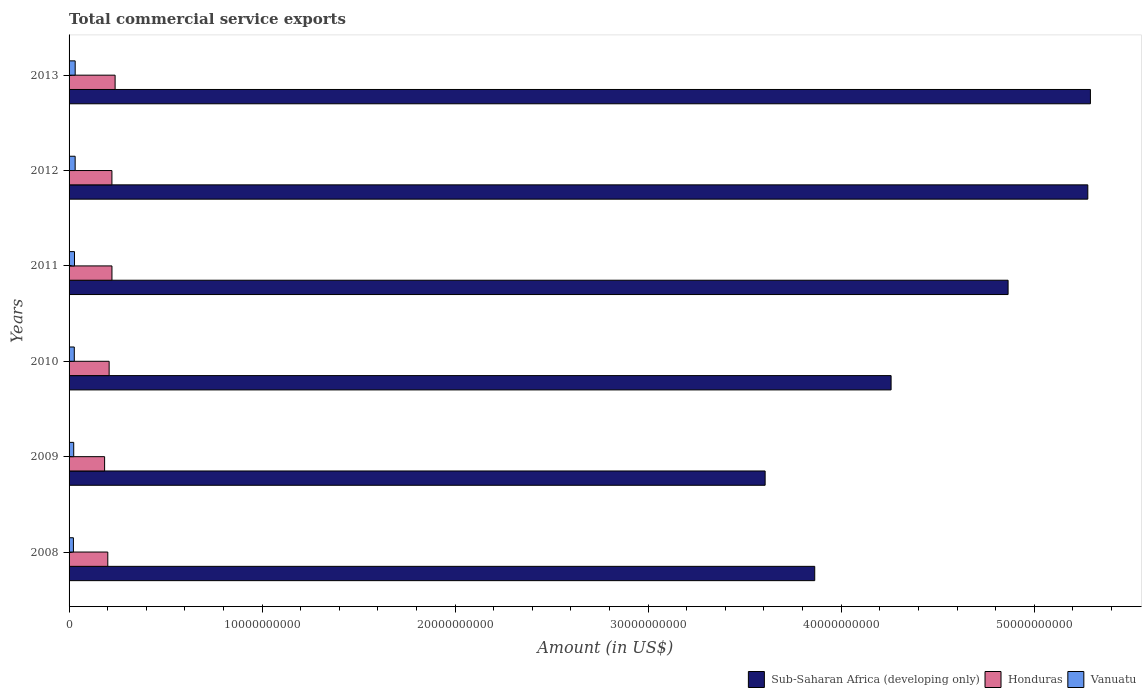How many groups of bars are there?
Your answer should be compact. 6. Are the number of bars per tick equal to the number of legend labels?
Make the answer very short. Yes. What is the label of the 1st group of bars from the top?
Provide a short and direct response. 2013. What is the total commercial service exports in Honduras in 2008?
Make the answer very short. 2.01e+09. Across all years, what is the maximum total commercial service exports in Vanuatu?
Offer a terse response. 3.17e+08. Across all years, what is the minimum total commercial service exports in Sub-Saharan Africa (developing only)?
Ensure brevity in your answer.  3.61e+1. What is the total total commercial service exports in Sub-Saharan Africa (developing only) in the graph?
Provide a succinct answer. 2.72e+11. What is the difference between the total commercial service exports in Sub-Saharan Africa (developing only) in 2010 and that in 2011?
Offer a very short reply. -6.06e+09. What is the difference between the total commercial service exports in Sub-Saharan Africa (developing only) in 2011 and the total commercial service exports in Vanuatu in 2012?
Ensure brevity in your answer.  4.83e+1. What is the average total commercial service exports in Honduras per year?
Offer a very short reply. 2.12e+09. In the year 2009, what is the difference between the total commercial service exports in Vanuatu and total commercial service exports in Sub-Saharan Africa (developing only)?
Offer a terse response. -3.58e+1. In how many years, is the total commercial service exports in Sub-Saharan Africa (developing only) greater than 30000000000 US$?
Ensure brevity in your answer.  6. What is the ratio of the total commercial service exports in Sub-Saharan Africa (developing only) in 2008 to that in 2013?
Ensure brevity in your answer.  0.73. What is the difference between the highest and the second highest total commercial service exports in Sub-Saharan Africa (developing only)?
Offer a terse response. 1.35e+08. What is the difference between the highest and the lowest total commercial service exports in Vanuatu?
Offer a terse response. 9.15e+07. What does the 1st bar from the top in 2011 represents?
Your answer should be very brief. Vanuatu. What does the 3rd bar from the bottom in 2012 represents?
Your answer should be very brief. Vanuatu. How many years are there in the graph?
Offer a terse response. 6. What is the difference between two consecutive major ticks on the X-axis?
Keep it short and to the point. 1.00e+1. Are the values on the major ticks of X-axis written in scientific E-notation?
Offer a terse response. No. Does the graph contain grids?
Ensure brevity in your answer.  No. Where does the legend appear in the graph?
Provide a succinct answer. Bottom right. How are the legend labels stacked?
Your answer should be very brief. Horizontal. What is the title of the graph?
Your answer should be very brief. Total commercial service exports. What is the Amount (in US$) in Sub-Saharan Africa (developing only) in 2008?
Give a very brief answer. 3.86e+1. What is the Amount (in US$) of Honduras in 2008?
Offer a terse response. 2.01e+09. What is the Amount (in US$) of Vanuatu in 2008?
Provide a short and direct response. 2.25e+08. What is the Amount (in US$) in Sub-Saharan Africa (developing only) in 2009?
Keep it short and to the point. 3.61e+1. What is the Amount (in US$) in Honduras in 2009?
Give a very brief answer. 1.84e+09. What is the Amount (in US$) of Vanuatu in 2009?
Your answer should be compact. 2.41e+08. What is the Amount (in US$) of Sub-Saharan Africa (developing only) in 2010?
Give a very brief answer. 4.26e+1. What is the Amount (in US$) in Honduras in 2010?
Provide a short and direct response. 2.08e+09. What is the Amount (in US$) in Vanuatu in 2010?
Your response must be concise. 2.71e+08. What is the Amount (in US$) in Sub-Saharan Africa (developing only) in 2011?
Keep it short and to the point. 4.86e+1. What is the Amount (in US$) of Honduras in 2011?
Provide a succinct answer. 2.22e+09. What is the Amount (in US$) of Vanuatu in 2011?
Ensure brevity in your answer.  2.81e+08. What is the Amount (in US$) in Sub-Saharan Africa (developing only) in 2012?
Provide a succinct answer. 5.28e+1. What is the Amount (in US$) in Honduras in 2012?
Make the answer very short. 2.22e+09. What is the Amount (in US$) of Vanuatu in 2012?
Your answer should be very brief. 3.15e+08. What is the Amount (in US$) of Sub-Saharan Africa (developing only) in 2013?
Provide a succinct answer. 5.29e+1. What is the Amount (in US$) of Honduras in 2013?
Give a very brief answer. 2.39e+09. What is the Amount (in US$) in Vanuatu in 2013?
Provide a short and direct response. 3.17e+08. Across all years, what is the maximum Amount (in US$) in Sub-Saharan Africa (developing only)?
Ensure brevity in your answer.  5.29e+1. Across all years, what is the maximum Amount (in US$) of Honduras?
Give a very brief answer. 2.39e+09. Across all years, what is the maximum Amount (in US$) of Vanuatu?
Make the answer very short. 3.17e+08. Across all years, what is the minimum Amount (in US$) of Sub-Saharan Africa (developing only)?
Ensure brevity in your answer.  3.61e+1. Across all years, what is the minimum Amount (in US$) in Honduras?
Make the answer very short. 1.84e+09. Across all years, what is the minimum Amount (in US$) in Vanuatu?
Your answer should be compact. 2.25e+08. What is the total Amount (in US$) of Sub-Saharan Africa (developing only) in the graph?
Ensure brevity in your answer.  2.72e+11. What is the total Amount (in US$) of Honduras in the graph?
Make the answer very short. 1.27e+1. What is the total Amount (in US$) in Vanuatu in the graph?
Keep it short and to the point. 1.65e+09. What is the difference between the Amount (in US$) of Sub-Saharan Africa (developing only) in 2008 and that in 2009?
Offer a very short reply. 2.57e+09. What is the difference between the Amount (in US$) of Honduras in 2008 and that in 2009?
Ensure brevity in your answer.  1.65e+08. What is the difference between the Amount (in US$) in Vanuatu in 2008 and that in 2009?
Make the answer very short. -1.57e+07. What is the difference between the Amount (in US$) in Sub-Saharan Africa (developing only) in 2008 and that in 2010?
Your answer should be very brief. -3.96e+09. What is the difference between the Amount (in US$) in Honduras in 2008 and that in 2010?
Provide a succinct answer. -6.97e+07. What is the difference between the Amount (in US$) in Vanuatu in 2008 and that in 2010?
Your response must be concise. -4.59e+07. What is the difference between the Amount (in US$) of Sub-Saharan Africa (developing only) in 2008 and that in 2011?
Offer a terse response. -1.00e+1. What is the difference between the Amount (in US$) of Honduras in 2008 and that in 2011?
Your answer should be compact. -2.15e+08. What is the difference between the Amount (in US$) in Vanuatu in 2008 and that in 2011?
Provide a succinct answer. -5.62e+07. What is the difference between the Amount (in US$) in Sub-Saharan Africa (developing only) in 2008 and that in 2012?
Your answer should be compact. -1.41e+1. What is the difference between the Amount (in US$) in Honduras in 2008 and that in 2012?
Offer a terse response. -2.14e+08. What is the difference between the Amount (in US$) of Vanuatu in 2008 and that in 2012?
Your response must be concise. -9.00e+07. What is the difference between the Amount (in US$) in Sub-Saharan Africa (developing only) in 2008 and that in 2013?
Keep it short and to the point. -1.43e+1. What is the difference between the Amount (in US$) of Honduras in 2008 and that in 2013?
Offer a very short reply. -3.79e+08. What is the difference between the Amount (in US$) of Vanuatu in 2008 and that in 2013?
Offer a terse response. -9.15e+07. What is the difference between the Amount (in US$) of Sub-Saharan Africa (developing only) in 2009 and that in 2010?
Your answer should be compact. -6.53e+09. What is the difference between the Amount (in US$) in Honduras in 2009 and that in 2010?
Offer a terse response. -2.35e+08. What is the difference between the Amount (in US$) of Vanuatu in 2009 and that in 2010?
Provide a short and direct response. -3.02e+07. What is the difference between the Amount (in US$) of Sub-Saharan Africa (developing only) in 2009 and that in 2011?
Make the answer very short. -1.26e+1. What is the difference between the Amount (in US$) in Honduras in 2009 and that in 2011?
Keep it short and to the point. -3.80e+08. What is the difference between the Amount (in US$) of Vanuatu in 2009 and that in 2011?
Your response must be concise. -4.05e+07. What is the difference between the Amount (in US$) in Sub-Saharan Africa (developing only) in 2009 and that in 2012?
Offer a very short reply. -1.67e+1. What is the difference between the Amount (in US$) in Honduras in 2009 and that in 2012?
Give a very brief answer. -3.79e+08. What is the difference between the Amount (in US$) in Vanuatu in 2009 and that in 2012?
Provide a short and direct response. -7.43e+07. What is the difference between the Amount (in US$) of Sub-Saharan Africa (developing only) in 2009 and that in 2013?
Your answer should be very brief. -1.69e+1. What is the difference between the Amount (in US$) of Honduras in 2009 and that in 2013?
Your answer should be very brief. -5.45e+08. What is the difference between the Amount (in US$) in Vanuatu in 2009 and that in 2013?
Keep it short and to the point. -7.58e+07. What is the difference between the Amount (in US$) of Sub-Saharan Africa (developing only) in 2010 and that in 2011?
Make the answer very short. -6.06e+09. What is the difference between the Amount (in US$) in Honduras in 2010 and that in 2011?
Ensure brevity in your answer.  -1.45e+08. What is the difference between the Amount (in US$) in Vanuatu in 2010 and that in 2011?
Offer a very short reply. -1.03e+07. What is the difference between the Amount (in US$) of Sub-Saharan Africa (developing only) in 2010 and that in 2012?
Provide a short and direct response. -1.02e+1. What is the difference between the Amount (in US$) in Honduras in 2010 and that in 2012?
Your answer should be very brief. -1.44e+08. What is the difference between the Amount (in US$) of Vanuatu in 2010 and that in 2012?
Make the answer very short. -4.41e+07. What is the difference between the Amount (in US$) in Sub-Saharan Africa (developing only) in 2010 and that in 2013?
Offer a very short reply. -1.03e+1. What is the difference between the Amount (in US$) in Honduras in 2010 and that in 2013?
Your answer should be compact. -3.10e+08. What is the difference between the Amount (in US$) in Vanuatu in 2010 and that in 2013?
Offer a terse response. -4.56e+07. What is the difference between the Amount (in US$) of Sub-Saharan Africa (developing only) in 2011 and that in 2012?
Give a very brief answer. -4.13e+09. What is the difference between the Amount (in US$) in Honduras in 2011 and that in 2012?
Your answer should be very brief. 1.30e+06. What is the difference between the Amount (in US$) of Vanuatu in 2011 and that in 2012?
Your answer should be compact. -3.38e+07. What is the difference between the Amount (in US$) in Sub-Saharan Africa (developing only) in 2011 and that in 2013?
Your answer should be compact. -4.27e+09. What is the difference between the Amount (in US$) in Honduras in 2011 and that in 2013?
Give a very brief answer. -1.64e+08. What is the difference between the Amount (in US$) in Vanuatu in 2011 and that in 2013?
Your answer should be compact. -3.53e+07. What is the difference between the Amount (in US$) of Sub-Saharan Africa (developing only) in 2012 and that in 2013?
Your response must be concise. -1.35e+08. What is the difference between the Amount (in US$) of Honduras in 2012 and that in 2013?
Give a very brief answer. -1.65e+08. What is the difference between the Amount (in US$) in Vanuatu in 2012 and that in 2013?
Ensure brevity in your answer.  -1.54e+06. What is the difference between the Amount (in US$) in Sub-Saharan Africa (developing only) in 2008 and the Amount (in US$) in Honduras in 2009?
Provide a succinct answer. 3.68e+1. What is the difference between the Amount (in US$) of Sub-Saharan Africa (developing only) in 2008 and the Amount (in US$) of Vanuatu in 2009?
Your answer should be compact. 3.84e+1. What is the difference between the Amount (in US$) in Honduras in 2008 and the Amount (in US$) in Vanuatu in 2009?
Give a very brief answer. 1.77e+09. What is the difference between the Amount (in US$) in Sub-Saharan Africa (developing only) in 2008 and the Amount (in US$) in Honduras in 2010?
Your response must be concise. 3.66e+1. What is the difference between the Amount (in US$) of Sub-Saharan Africa (developing only) in 2008 and the Amount (in US$) of Vanuatu in 2010?
Make the answer very short. 3.84e+1. What is the difference between the Amount (in US$) in Honduras in 2008 and the Amount (in US$) in Vanuatu in 2010?
Your answer should be very brief. 1.73e+09. What is the difference between the Amount (in US$) in Sub-Saharan Africa (developing only) in 2008 and the Amount (in US$) in Honduras in 2011?
Give a very brief answer. 3.64e+1. What is the difference between the Amount (in US$) in Sub-Saharan Africa (developing only) in 2008 and the Amount (in US$) in Vanuatu in 2011?
Offer a very short reply. 3.83e+1. What is the difference between the Amount (in US$) of Honduras in 2008 and the Amount (in US$) of Vanuatu in 2011?
Give a very brief answer. 1.72e+09. What is the difference between the Amount (in US$) of Sub-Saharan Africa (developing only) in 2008 and the Amount (in US$) of Honduras in 2012?
Keep it short and to the point. 3.64e+1. What is the difference between the Amount (in US$) in Sub-Saharan Africa (developing only) in 2008 and the Amount (in US$) in Vanuatu in 2012?
Provide a succinct answer. 3.83e+1. What is the difference between the Amount (in US$) of Honduras in 2008 and the Amount (in US$) of Vanuatu in 2012?
Give a very brief answer. 1.69e+09. What is the difference between the Amount (in US$) of Sub-Saharan Africa (developing only) in 2008 and the Amount (in US$) of Honduras in 2013?
Provide a succinct answer. 3.62e+1. What is the difference between the Amount (in US$) in Sub-Saharan Africa (developing only) in 2008 and the Amount (in US$) in Vanuatu in 2013?
Make the answer very short. 3.83e+1. What is the difference between the Amount (in US$) in Honduras in 2008 and the Amount (in US$) in Vanuatu in 2013?
Keep it short and to the point. 1.69e+09. What is the difference between the Amount (in US$) of Sub-Saharan Africa (developing only) in 2009 and the Amount (in US$) of Honduras in 2010?
Ensure brevity in your answer.  3.40e+1. What is the difference between the Amount (in US$) of Sub-Saharan Africa (developing only) in 2009 and the Amount (in US$) of Vanuatu in 2010?
Make the answer very short. 3.58e+1. What is the difference between the Amount (in US$) of Honduras in 2009 and the Amount (in US$) of Vanuatu in 2010?
Make the answer very short. 1.57e+09. What is the difference between the Amount (in US$) in Sub-Saharan Africa (developing only) in 2009 and the Amount (in US$) in Honduras in 2011?
Provide a short and direct response. 3.38e+1. What is the difference between the Amount (in US$) in Sub-Saharan Africa (developing only) in 2009 and the Amount (in US$) in Vanuatu in 2011?
Your answer should be compact. 3.58e+1. What is the difference between the Amount (in US$) in Honduras in 2009 and the Amount (in US$) in Vanuatu in 2011?
Keep it short and to the point. 1.56e+09. What is the difference between the Amount (in US$) of Sub-Saharan Africa (developing only) in 2009 and the Amount (in US$) of Honduras in 2012?
Offer a terse response. 3.38e+1. What is the difference between the Amount (in US$) of Sub-Saharan Africa (developing only) in 2009 and the Amount (in US$) of Vanuatu in 2012?
Your response must be concise. 3.57e+1. What is the difference between the Amount (in US$) of Honduras in 2009 and the Amount (in US$) of Vanuatu in 2012?
Give a very brief answer. 1.53e+09. What is the difference between the Amount (in US$) of Sub-Saharan Africa (developing only) in 2009 and the Amount (in US$) of Honduras in 2013?
Ensure brevity in your answer.  3.37e+1. What is the difference between the Amount (in US$) in Sub-Saharan Africa (developing only) in 2009 and the Amount (in US$) in Vanuatu in 2013?
Offer a terse response. 3.57e+1. What is the difference between the Amount (in US$) of Honduras in 2009 and the Amount (in US$) of Vanuatu in 2013?
Provide a short and direct response. 1.52e+09. What is the difference between the Amount (in US$) of Sub-Saharan Africa (developing only) in 2010 and the Amount (in US$) of Honduras in 2011?
Provide a succinct answer. 4.04e+1. What is the difference between the Amount (in US$) of Sub-Saharan Africa (developing only) in 2010 and the Amount (in US$) of Vanuatu in 2011?
Give a very brief answer. 4.23e+1. What is the difference between the Amount (in US$) of Honduras in 2010 and the Amount (in US$) of Vanuatu in 2011?
Provide a short and direct response. 1.79e+09. What is the difference between the Amount (in US$) of Sub-Saharan Africa (developing only) in 2010 and the Amount (in US$) of Honduras in 2012?
Ensure brevity in your answer.  4.04e+1. What is the difference between the Amount (in US$) in Sub-Saharan Africa (developing only) in 2010 and the Amount (in US$) in Vanuatu in 2012?
Your response must be concise. 4.23e+1. What is the difference between the Amount (in US$) in Honduras in 2010 and the Amount (in US$) in Vanuatu in 2012?
Your answer should be compact. 1.76e+09. What is the difference between the Amount (in US$) in Sub-Saharan Africa (developing only) in 2010 and the Amount (in US$) in Honduras in 2013?
Offer a very short reply. 4.02e+1. What is the difference between the Amount (in US$) of Sub-Saharan Africa (developing only) in 2010 and the Amount (in US$) of Vanuatu in 2013?
Offer a very short reply. 4.23e+1. What is the difference between the Amount (in US$) in Honduras in 2010 and the Amount (in US$) in Vanuatu in 2013?
Offer a very short reply. 1.76e+09. What is the difference between the Amount (in US$) in Sub-Saharan Africa (developing only) in 2011 and the Amount (in US$) in Honduras in 2012?
Keep it short and to the point. 4.64e+1. What is the difference between the Amount (in US$) of Sub-Saharan Africa (developing only) in 2011 and the Amount (in US$) of Vanuatu in 2012?
Keep it short and to the point. 4.83e+1. What is the difference between the Amount (in US$) of Honduras in 2011 and the Amount (in US$) of Vanuatu in 2012?
Your answer should be very brief. 1.91e+09. What is the difference between the Amount (in US$) in Sub-Saharan Africa (developing only) in 2011 and the Amount (in US$) in Honduras in 2013?
Keep it short and to the point. 4.63e+1. What is the difference between the Amount (in US$) in Sub-Saharan Africa (developing only) in 2011 and the Amount (in US$) in Vanuatu in 2013?
Your answer should be very brief. 4.83e+1. What is the difference between the Amount (in US$) in Honduras in 2011 and the Amount (in US$) in Vanuatu in 2013?
Your answer should be very brief. 1.90e+09. What is the difference between the Amount (in US$) of Sub-Saharan Africa (developing only) in 2012 and the Amount (in US$) of Honduras in 2013?
Give a very brief answer. 5.04e+1. What is the difference between the Amount (in US$) in Sub-Saharan Africa (developing only) in 2012 and the Amount (in US$) in Vanuatu in 2013?
Your answer should be compact. 5.25e+1. What is the difference between the Amount (in US$) of Honduras in 2012 and the Amount (in US$) of Vanuatu in 2013?
Give a very brief answer. 1.90e+09. What is the average Amount (in US$) of Sub-Saharan Africa (developing only) per year?
Give a very brief answer. 4.53e+1. What is the average Amount (in US$) in Honduras per year?
Give a very brief answer. 2.12e+09. What is the average Amount (in US$) in Vanuatu per year?
Your answer should be compact. 2.75e+08. In the year 2008, what is the difference between the Amount (in US$) in Sub-Saharan Africa (developing only) and Amount (in US$) in Honduras?
Your answer should be compact. 3.66e+1. In the year 2008, what is the difference between the Amount (in US$) in Sub-Saharan Africa (developing only) and Amount (in US$) in Vanuatu?
Offer a very short reply. 3.84e+1. In the year 2008, what is the difference between the Amount (in US$) of Honduras and Amount (in US$) of Vanuatu?
Keep it short and to the point. 1.78e+09. In the year 2009, what is the difference between the Amount (in US$) in Sub-Saharan Africa (developing only) and Amount (in US$) in Honduras?
Offer a very short reply. 3.42e+1. In the year 2009, what is the difference between the Amount (in US$) in Sub-Saharan Africa (developing only) and Amount (in US$) in Vanuatu?
Offer a terse response. 3.58e+1. In the year 2009, what is the difference between the Amount (in US$) in Honduras and Amount (in US$) in Vanuatu?
Ensure brevity in your answer.  1.60e+09. In the year 2010, what is the difference between the Amount (in US$) of Sub-Saharan Africa (developing only) and Amount (in US$) of Honduras?
Your answer should be compact. 4.05e+1. In the year 2010, what is the difference between the Amount (in US$) in Sub-Saharan Africa (developing only) and Amount (in US$) in Vanuatu?
Your answer should be very brief. 4.23e+1. In the year 2010, what is the difference between the Amount (in US$) of Honduras and Amount (in US$) of Vanuatu?
Keep it short and to the point. 1.80e+09. In the year 2011, what is the difference between the Amount (in US$) in Sub-Saharan Africa (developing only) and Amount (in US$) in Honduras?
Offer a very short reply. 4.64e+1. In the year 2011, what is the difference between the Amount (in US$) of Sub-Saharan Africa (developing only) and Amount (in US$) of Vanuatu?
Make the answer very short. 4.84e+1. In the year 2011, what is the difference between the Amount (in US$) of Honduras and Amount (in US$) of Vanuatu?
Offer a terse response. 1.94e+09. In the year 2012, what is the difference between the Amount (in US$) of Sub-Saharan Africa (developing only) and Amount (in US$) of Honduras?
Provide a succinct answer. 5.06e+1. In the year 2012, what is the difference between the Amount (in US$) of Sub-Saharan Africa (developing only) and Amount (in US$) of Vanuatu?
Your answer should be very brief. 5.25e+1. In the year 2012, what is the difference between the Amount (in US$) of Honduras and Amount (in US$) of Vanuatu?
Offer a very short reply. 1.90e+09. In the year 2013, what is the difference between the Amount (in US$) in Sub-Saharan Africa (developing only) and Amount (in US$) in Honduras?
Your response must be concise. 5.05e+1. In the year 2013, what is the difference between the Amount (in US$) of Sub-Saharan Africa (developing only) and Amount (in US$) of Vanuatu?
Ensure brevity in your answer.  5.26e+1. In the year 2013, what is the difference between the Amount (in US$) of Honduras and Amount (in US$) of Vanuatu?
Give a very brief answer. 2.07e+09. What is the ratio of the Amount (in US$) of Sub-Saharan Africa (developing only) in 2008 to that in 2009?
Your response must be concise. 1.07. What is the ratio of the Amount (in US$) of Honduras in 2008 to that in 2009?
Offer a terse response. 1.09. What is the ratio of the Amount (in US$) in Vanuatu in 2008 to that in 2009?
Keep it short and to the point. 0.93. What is the ratio of the Amount (in US$) of Sub-Saharan Africa (developing only) in 2008 to that in 2010?
Ensure brevity in your answer.  0.91. What is the ratio of the Amount (in US$) in Honduras in 2008 to that in 2010?
Keep it short and to the point. 0.97. What is the ratio of the Amount (in US$) in Vanuatu in 2008 to that in 2010?
Your response must be concise. 0.83. What is the ratio of the Amount (in US$) of Sub-Saharan Africa (developing only) in 2008 to that in 2011?
Provide a short and direct response. 0.79. What is the ratio of the Amount (in US$) of Honduras in 2008 to that in 2011?
Provide a short and direct response. 0.9. What is the ratio of the Amount (in US$) of Vanuatu in 2008 to that in 2011?
Your response must be concise. 0.8. What is the ratio of the Amount (in US$) in Sub-Saharan Africa (developing only) in 2008 to that in 2012?
Your answer should be very brief. 0.73. What is the ratio of the Amount (in US$) in Honduras in 2008 to that in 2012?
Offer a very short reply. 0.9. What is the ratio of the Amount (in US$) of Vanuatu in 2008 to that in 2012?
Provide a succinct answer. 0.71. What is the ratio of the Amount (in US$) of Sub-Saharan Africa (developing only) in 2008 to that in 2013?
Keep it short and to the point. 0.73. What is the ratio of the Amount (in US$) of Honduras in 2008 to that in 2013?
Provide a succinct answer. 0.84. What is the ratio of the Amount (in US$) in Vanuatu in 2008 to that in 2013?
Offer a terse response. 0.71. What is the ratio of the Amount (in US$) in Sub-Saharan Africa (developing only) in 2009 to that in 2010?
Offer a very short reply. 0.85. What is the ratio of the Amount (in US$) of Honduras in 2009 to that in 2010?
Your answer should be compact. 0.89. What is the ratio of the Amount (in US$) in Vanuatu in 2009 to that in 2010?
Give a very brief answer. 0.89. What is the ratio of the Amount (in US$) of Sub-Saharan Africa (developing only) in 2009 to that in 2011?
Keep it short and to the point. 0.74. What is the ratio of the Amount (in US$) of Honduras in 2009 to that in 2011?
Your answer should be very brief. 0.83. What is the ratio of the Amount (in US$) in Vanuatu in 2009 to that in 2011?
Make the answer very short. 0.86. What is the ratio of the Amount (in US$) of Sub-Saharan Africa (developing only) in 2009 to that in 2012?
Ensure brevity in your answer.  0.68. What is the ratio of the Amount (in US$) in Honduras in 2009 to that in 2012?
Offer a terse response. 0.83. What is the ratio of the Amount (in US$) in Vanuatu in 2009 to that in 2012?
Provide a succinct answer. 0.76. What is the ratio of the Amount (in US$) of Sub-Saharan Africa (developing only) in 2009 to that in 2013?
Offer a very short reply. 0.68. What is the ratio of the Amount (in US$) in Honduras in 2009 to that in 2013?
Offer a terse response. 0.77. What is the ratio of the Amount (in US$) in Vanuatu in 2009 to that in 2013?
Ensure brevity in your answer.  0.76. What is the ratio of the Amount (in US$) in Sub-Saharan Africa (developing only) in 2010 to that in 2011?
Make the answer very short. 0.88. What is the ratio of the Amount (in US$) in Honduras in 2010 to that in 2011?
Give a very brief answer. 0.93. What is the ratio of the Amount (in US$) in Vanuatu in 2010 to that in 2011?
Give a very brief answer. 0.96. What is the ratio of the Amount (in US$) of Sub-Saharan Africa (developing only) in 2010 to that in 2012?
Ensure brevity in your answer.  0.81. What is the ratio of the Amount (in US$) of Honduras in 2010 to that in 2012?
Your answer should be very brief. 0.94. What is the ratio of the Amount (in US$) of Vanuatu in 2010 to that in 2012?
Your response must be concise. 0.86. What is the ratio of the Amount (in US$) of Sub-Saharan Africa (developing only) in 2010 to that in 2013?
Ensure brevity in your answer.  0.8. What is the ratio of the Amount (in US$) in Honduras in 2010 to that in 2013?
Ensure brevity in your answer.  0.87. What is the ratio of the Amount (in US$) of Vanuatu in 2010 to that in 2013?
Keep it short and to the point. 0.86. What is the ratio of the Amount (in US$) in Sub-Saharan Africa (developing only) in 2011 to that in 2012?
Make the answer very short. 0.92. What is the ratio of the Amount (in US$) in Vanuatu in 2011 to that in 2012?
Offer a very short reply. 0.89. What is the ratio of the Amount (in US$) in Sub-Saharan Africa (developing only) in 2011 to that in 2013?
Give a very brief answer. 0.92. What is the ratio of the Amount (in US$) of Honduras in 2011 to that in 2013?
Provide a succinct answer. 0.93. What is the ratio of the Amount (in US$) of Vanuatu in 2011 to that in 2013?
Your answer should be compact. 0.89. What is the ratio of the Amount (in US$) in Honduras in 2012 to that in 2013?
Your answer should be very brief. 0.93. What is the ratio of the Amount (in US$) of Vanuatu in 2012 to that in 2013?
Offer a very short reply. 1. What is the difference between the highest and the second highest Amount (in US$) in Sub-Saharan Africa (developing only)?
Your answer should be compact. 1.35e+08. What is the difference between the highest and the second highest Amount (in US$) of Honduras?
Provide a short and direct response. 1.64e+08. What is the difference between the highest and the second highest Amount (in US$) of Vanuatu?
Your response must be concise. 1.54e+06. What is the difference between the highest and the lowest Amount (in US$) in Sub-Saharan Africa (developing only)?
Provide a succinct answer. 1.69e+1. What is the difference between the highest and the lowest Amount (in US$) of Honduras?
Your response must be concise. 5.45e+08. What is the difference between the highest and the lowest Amount (in US$) in Vanuatu?
Provide a short and direct response. 9.15e+07. 